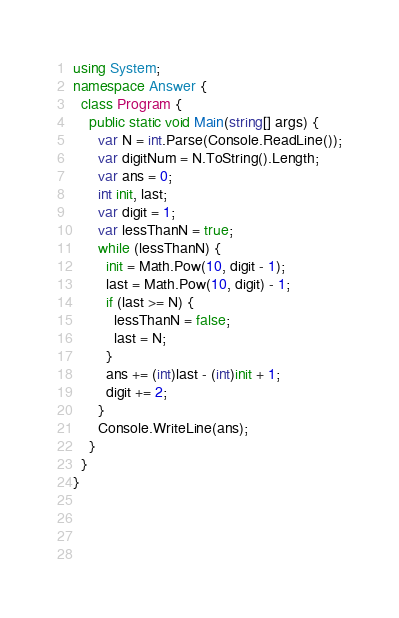<code> <loc_0><loc_0><loc_500><loc_500><_C#_>using System;
namespace Answer {
  class Program {
    public static void Main(string[] args) {
      var N = int.Parse(Console.ReadLine());
      var digitNum = N.ToString().Length;
      var ans = 0;
      int init, last;
      var digit = 1;
      var lessThanN = true;
      while (lessThanN) {
        init = Math.Pow(10, digit - 1);
        last = Math.Pow(10, digit) - 1;
        if (last >= N) {
          lessThanN = false;
          last = N;
        }
        ans += (int)last - (int)init + 1;
        digit += 2;
      }
      Console.WriteLine(ans);
    }
  }
}
        
        
        
      
</code> 